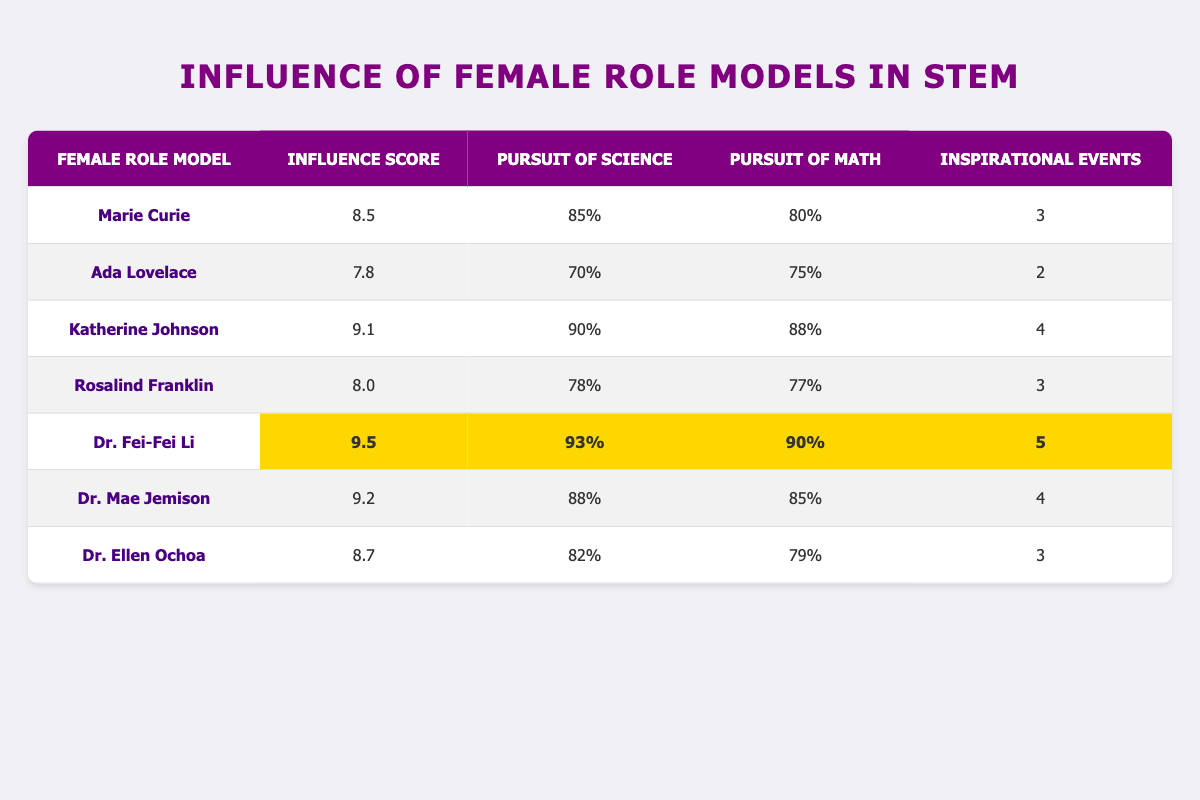What is the influence score of Dr. Fei-Fei Li? The table shows that the influence score for Dr. Fei-Fei Li is listed under the "Influence Score" column. It directly states the score is 9.5.
Answer: 9.5 Which female role model has the highest pursuit of science percentage? By reviewing the "Pursuit of Science" column, the highest value is 93%, corresponding to Dr. Fei-Fei Li.
Answer: Dr. Fei-Fei Li Is the influence score of Rosalind Franklin greater than 8? Looking at the "Influence Score" row for Rosalind Franklin, it shows a value of 8.0 which is not greater than 8. Thus, the answer is no.
Answer: No What is the average pursuit of math among all role models? First, we sum the "Pursuit of Math" percentages: 80 + 75 + 88 + 77 + 90 + 85 + 79 = 574. Next, we divide the total by the number of role models (7): 574/7 = 82. Therefore, the average is 82.
Answer: 82 How many inspirational events did the female role models have in total? By adding the "Inspirational Events" values: 3 + 2 + 4 + 3 + 5 + 4 + 3 = 24. This shows that the total number of inspirational events is 24.
Answer: 24 Which role model's influence score is closest to 9? Looking through the "Influence Score" column, we see that the scores of Katherine Johnson (9.1), Dr. Mae Jemison (9.2), and Dr. Fei-Fei Li (9.5) are all close to 9, but Dr. Mae Jemison at 9.2 is the closest.
Answer: Dr. Mae Jemison Does Ada Lovelace have more or fewer inspirational events compared to Dr. Ellen Ochoa? Ada Lovelace has 2 inspirational events, while Dr. Ellen Ochoa has 3. Since 2 is fewer than 3, the answer is no.
Answer: No What is the difference in the pursuit of math between Dr. Fei-Fei Li and Rosalind Franklin? The pursuit of math for Dr. Fei-Fei Li is 90% and for Rosalind Franklin is 77%. The difference is 90 - 77 = 13%.
Answer: 13 